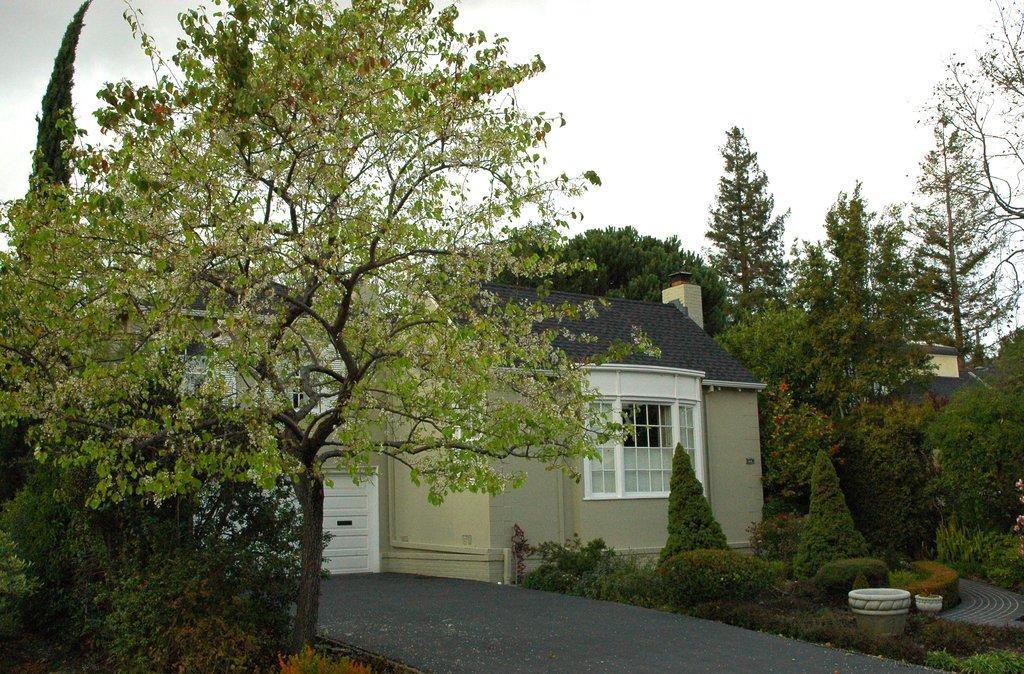Please provide a concise description of this image. In this image I can see few houses in white and cream color, trees in green color and the sky is in white color. 